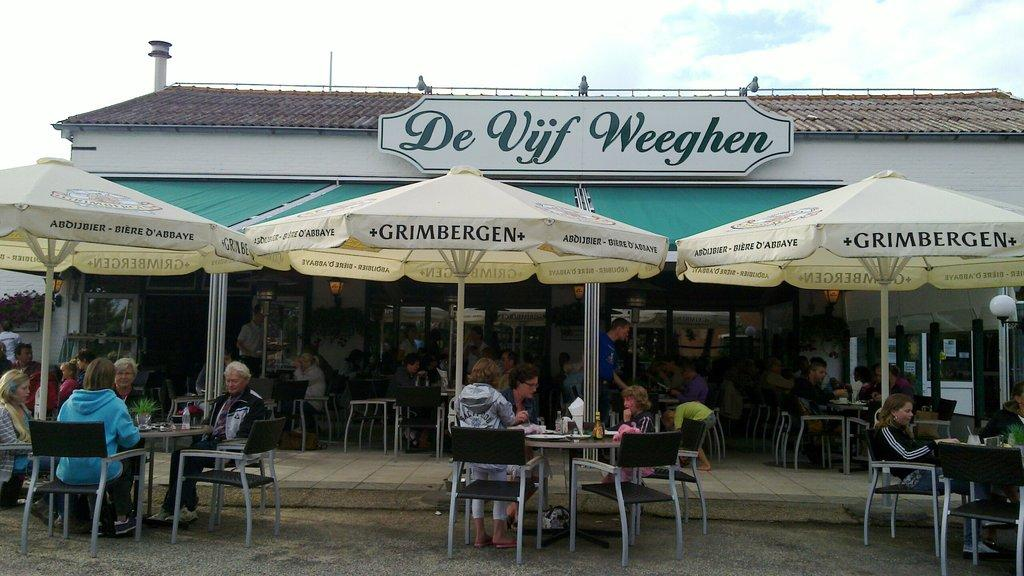What are the people in the image doing? People are sitting on chairs in the image. What objects are in front of the chairs? There are tables in front of the chairs in the image. What can be found on the tables? Bottles are present on the tables, along with other things. What type of protection from the sun or rain is visible? Umbrellas are visible in the scene. What provides illumination in the image? There are lights in the scene. What type of advertisement or signage is present? A hoarding is present in the image. What type of disease is spreading among the people in the image? There is no indication of any disease in the image; people are simply sitting on chairs. What type of cracker is being served on the tables in the image? There is no mention of crackers in the image; only bottles and other unspecified items are present on the tables. 